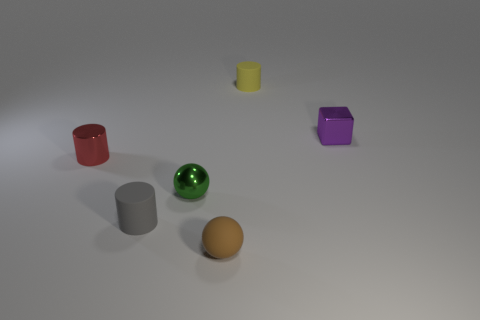There is a thing that is both in front of the tiny shiny cube and right of the shiny ball; what color is it?
Your answer should be compact. Brown. What number of green metallic objects are the same shape as the tiny brown rubber thing?
Provide a succinct answer. 1. What is the color of the metallic sphere that is the same size as the gray rubber thing?
Your response must be concise. Green. What color is the small metallic thing that is to the right of the matte ball left of the tiny matte cylinder behind the purple object?
Give a very brief answer. Purple. There is a purple metal thing; is its size the same as the rubber cylinder that is on the right side of the rubber ball?
Your answer should be compact. Yes. How many things are either large brown metal spheres or small green spheres?
Your answer should be compact. 1. Are there any tiny gray cylinders that have the same material as the cube?
Offer a terse response. No. There is a rubber cylinder that is in front of the small metallic object that is to the left of the metal sphere; what is its color?
Keep it short and to the point. Gray. Is the purple metal object the same size as the yellow cylinder?
Keep it short and to the point. Yes. What number of cylinders are either metal things or tiny purple metal objects?
Offer a very short reply. 1. 